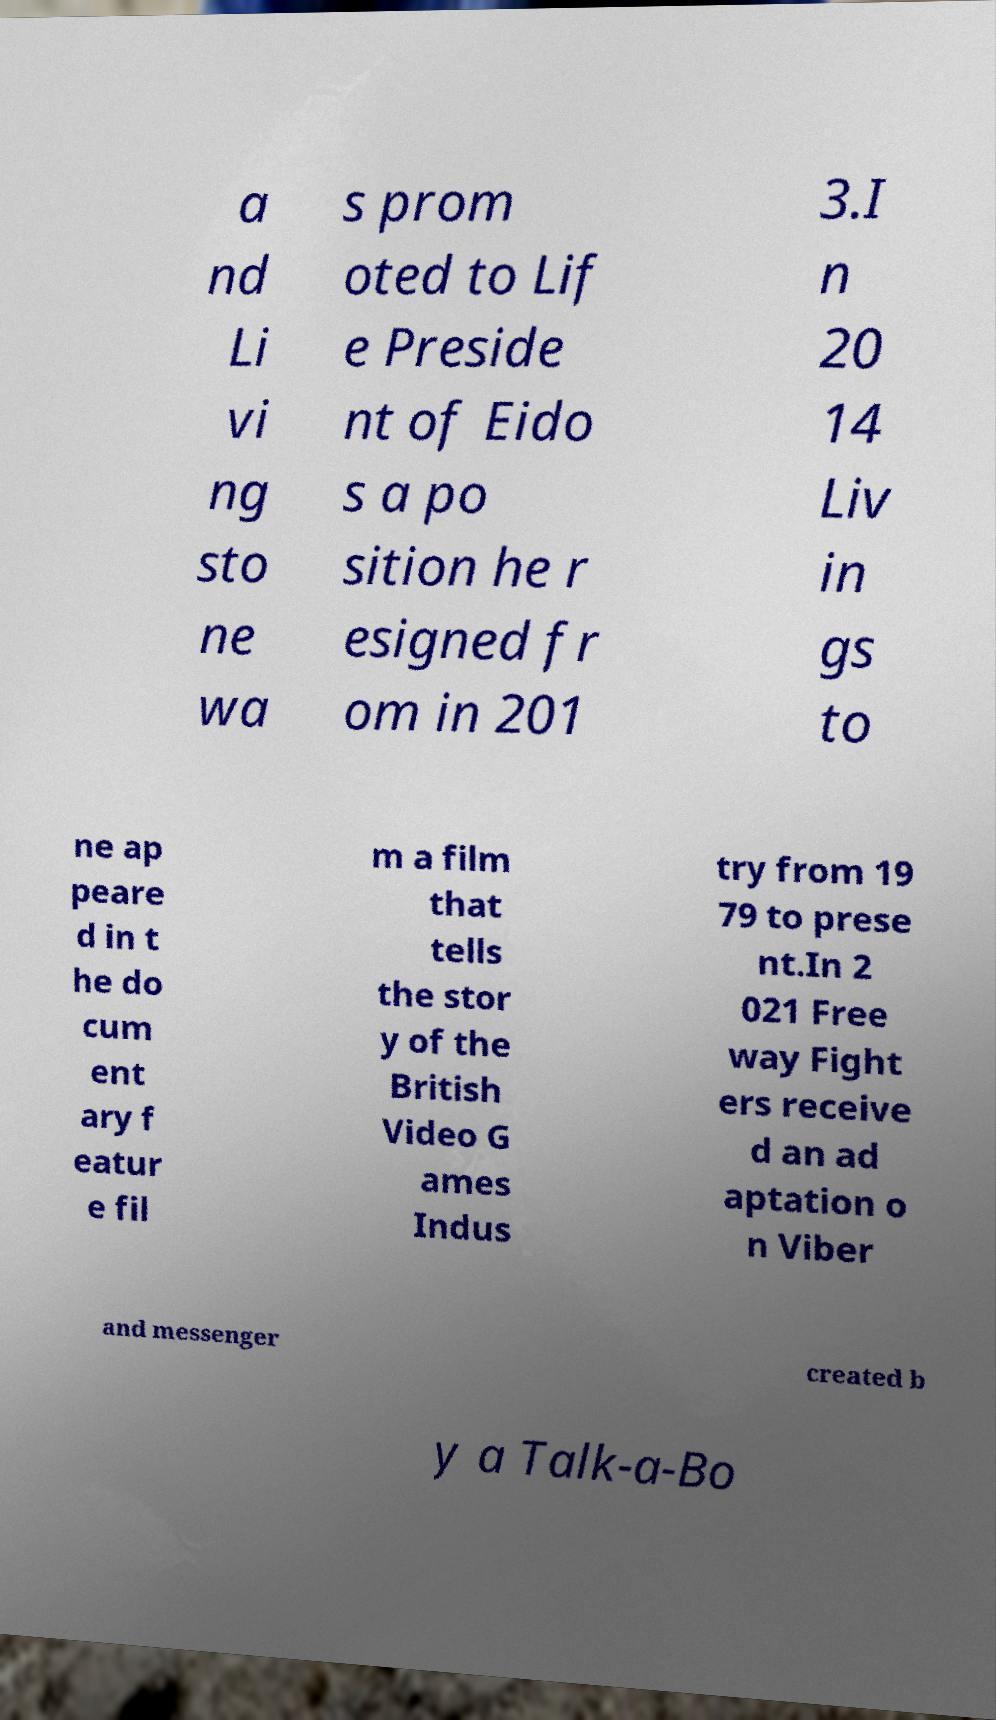Could you assist in decoding the text presented in this image and type it out clearly? a nd Li vi ng sto ne wa s prom oted to Lif e Preside nt of Eido s a po sition he r esigned fr om in 201 3.I n 20 14 Liv in gs to ne ap peare d in t he do cum ent ary f eatur e fil m a film that tells the stor y of the British Video G ames Indus try from 19 79 to prese nt.In 2 021 Free way Fight ers receive d an ad aptation o n Viber and messenger created b y a Talk-a-Bo 